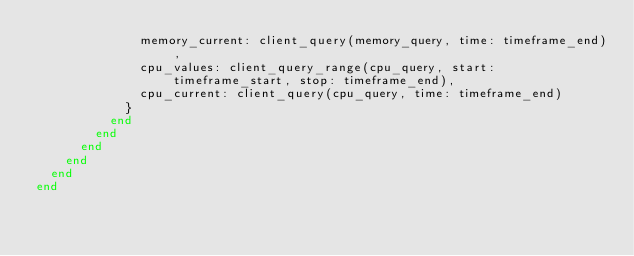<code> <loc_0><loc_0><loc_500><loc_500><_Ruby_>              memory_current: client_query(memory_query, time: timeframe_end),
              cpu_values: client_query_range(cpu_query, start: timeframe_start, stop: timeframe_end),
              cpu_current: client_query(cpu_query, time: timeframe_end)
            }
          end
        end
      end
    end
  end
end
</code> 